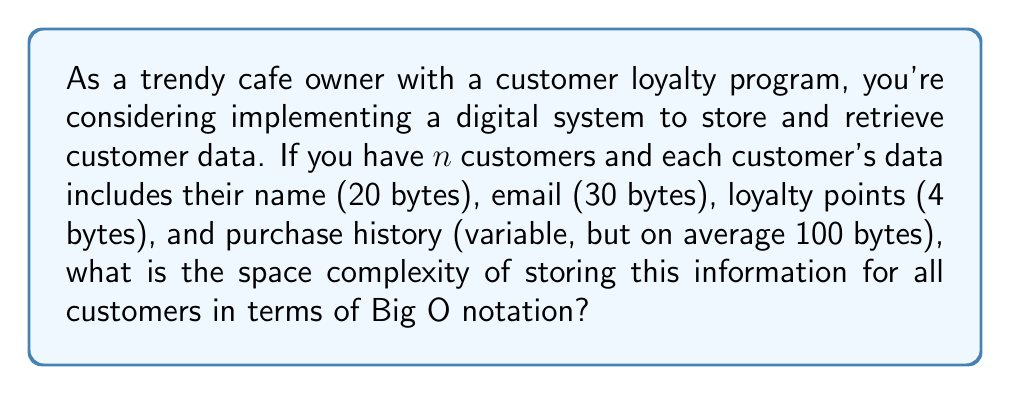Help me with this question. To determine the space complexity, we need to analyze the amount of memory required to store the data for all customers:

1. Fixed-size data per customer:
   - Name: 20 bytes
   - Email: 30 bytes
   - Loyalty points: 4 bytes
   Total fixed-size data: 54 bytes

2. Variable-size data per customer:
   - Purchase history: average 100 bytes

3. Total data per customer:
   54 bytes (fixed) + 100 bytes (variable) = 154 bytes

4. For $n$ customers, the total space required is:
   $$ 154n \text{ bytes} $$

In Big O notation, we focus on the growth rate of the space requirement as $n$ increases. The space complexity is directly proportional to the number of customers, $n$. Constants are dropped in Big O notation, so we can simplify 154n to just n.

Therefore, the space complexity of storing this customer data is $O(n)$, which is linear space complexity.

For retrieving data, assuming we use a hash table for quick access:
- The hash table itself would require $O(n)$ space to store all customer records.
- Retrieval time would be $O(1)$ on average, but this doesn't affect the space complexity.

The overall space complexity remains $O(n)$, as the dominant factor is the storage of customer data, which grows linearly with the number of customers.
Answer: $O(n)$ 